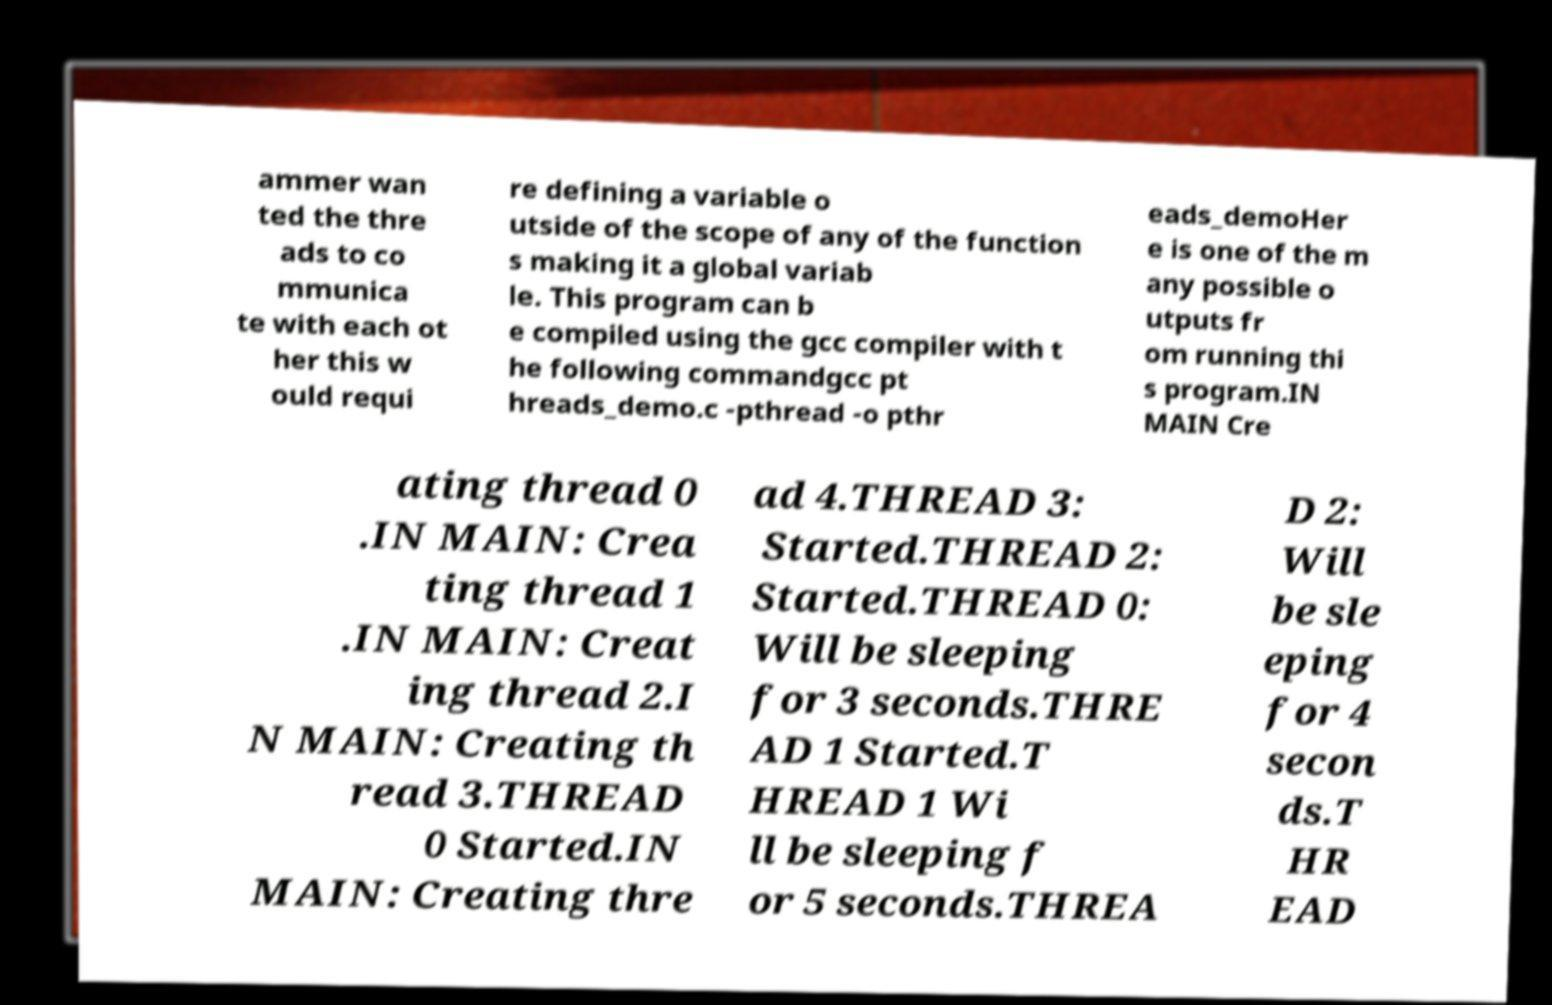Please identify and transcribe the text found in this image. ammer wan ted the thre ads to co mmunica te with each ot her this w ould requi re defining a variable o utside of the scope of any of the function s making it a global variab le. This program can b e compiled using the gcc compiler with t he following commandgcc pt hreads_demo.c -pthread -o pthr eads_demoHer e is one of the m any possible o utputs fr om running thi s program.IN MAIN Cre ating thread 0 .IN MAIN: Crea ting thread 1 .IN MAIN: Creat ing thread 2.I N MAIN: Creating th read 3.THREAD 0 Started.IN MAIN: Creating thre ad 4.THREAD 3: Started.THREAD 2: Started.THREAD 0: Will be sleeping for 3 seconds.THRE AD 1 Started.T HREAD 1 Wi ll be sleeping f or 5 seconds.THREA D 2: Will be sle eping for 4 secon ds.T HR EAD 